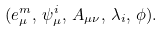<formula> <loc_0><loc_0><loc_500><loc_500>( e _ { \mu } ^ { m } , \, \psi _ { \mu } ^ { i } , \, A _ { \mu \nu } , \, \lambda _ { i } , \, \phi ) .</formula> 